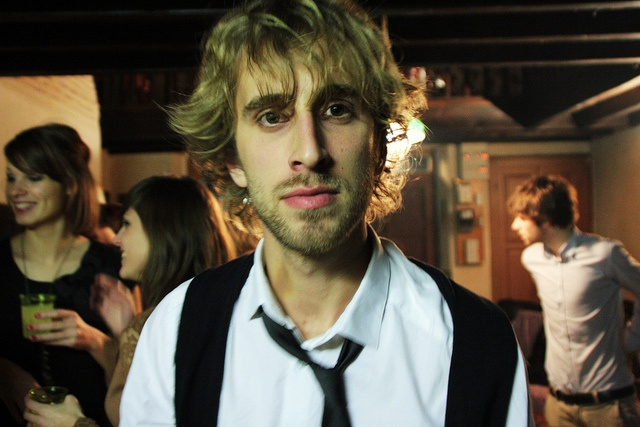Describe the objects in this image and their specific colors. I can see people in black, lightgray, olive, and tan tones, people in black, olive, maroon, and gray tones, people in black, beige, maroon, and tan tones, backpack in black, gray, maroon, and lightgray tones, and people in black, olive, tan, and maroon tones in this image. 